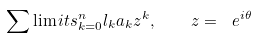<formula> <loc_0><loc_0><loc_500><loc_500>\sum \lim i t s _ { k = 0 } ^ { n } { l _ { k } a _ { k } z ^ { k } } , \quad z = \ e ^ { i \theta }</formula> 